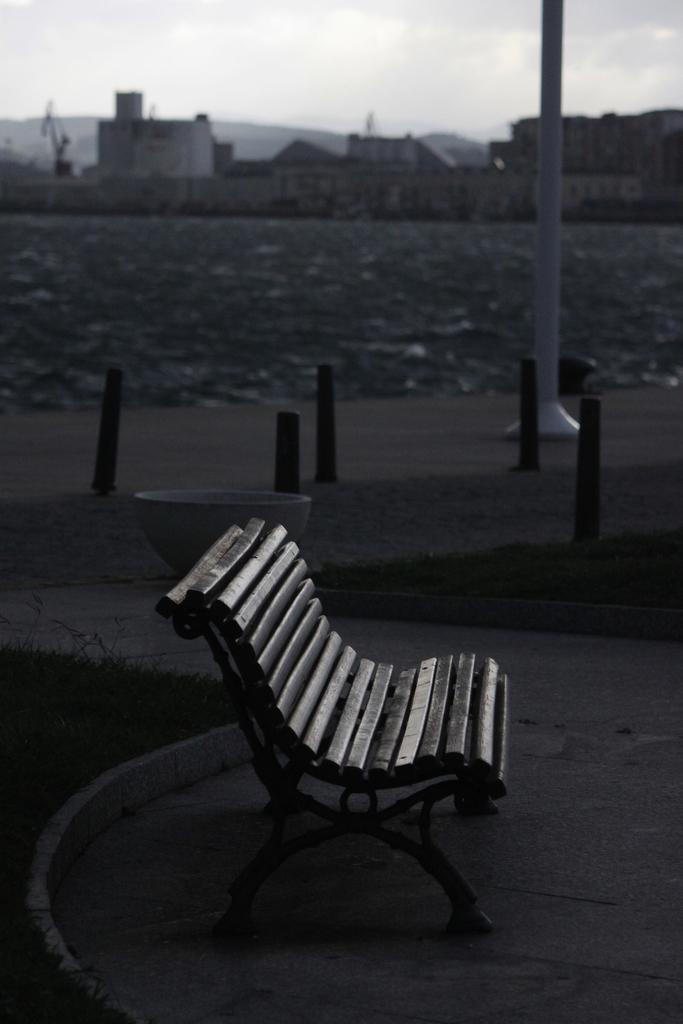What type of seating is visible in the image? There is a bench in the image. What can be seen in the background of the image? There are poles and houses in the background of the image. What is the color scheme of the image? The image is in black and white. Where is the basketball located in the image? There is no basketball present in the image. What type of beast can be seen hiding behind the bench in the image? There is no beast present in the image; it only features a bench, poles, houses, and a black and white color scheme. 